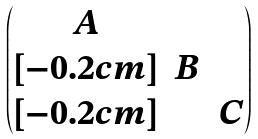<formula> <loc_0><loc_0><loc_500><loc_500>\begin{pmatrix} A & & \\ [ - 0 . 2 c m ] & B & \\ [ - 0 . 2 c m ] & & C \end{pmatrix}</formula> 